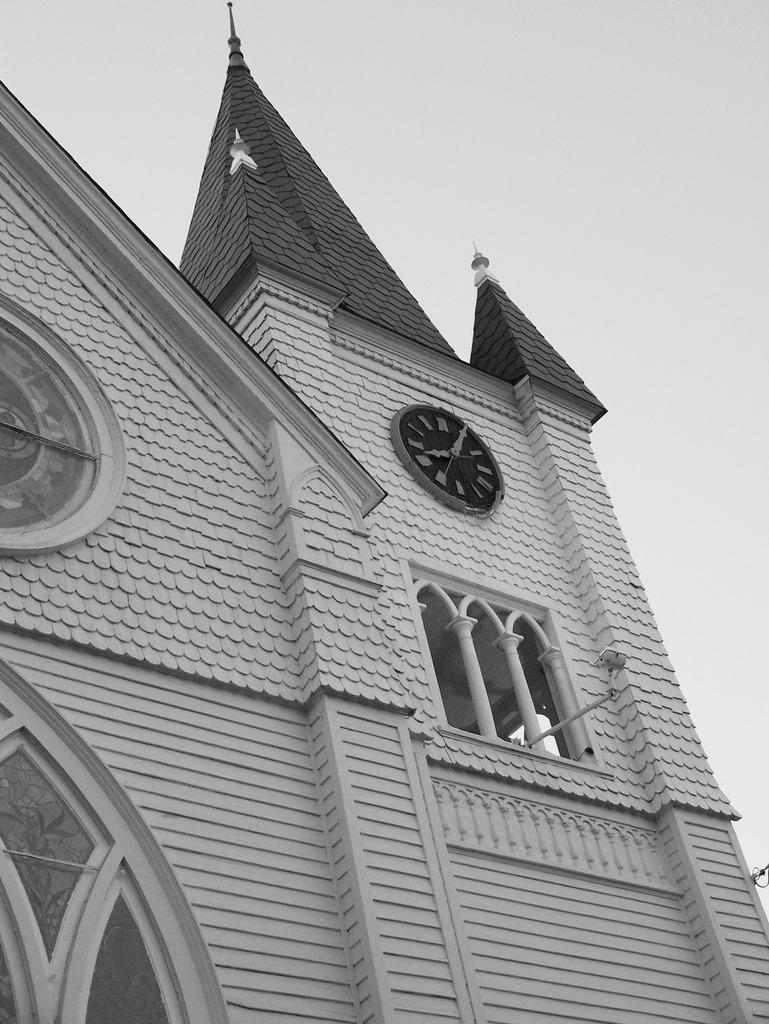Could you give a brief overview of what you see in this image? In this image I can see the building. I can see the clock to the building. In the background I can see the sky and this is a black and white image. 